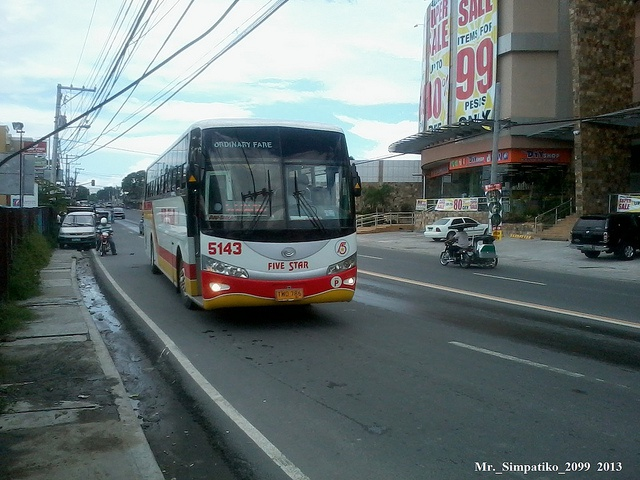Describe the objects in this image and their specific colors. I can see bus in white, black, gray, darkgray, and blue tones, truck in white, black, purple, and darkblue tones, car in white, black, gray, and darkgray tones, car in lightblue, darkgray, black, and gray tones, and motorcycle in lightblue, black, purple, gray, and darkgray tones in this image. 